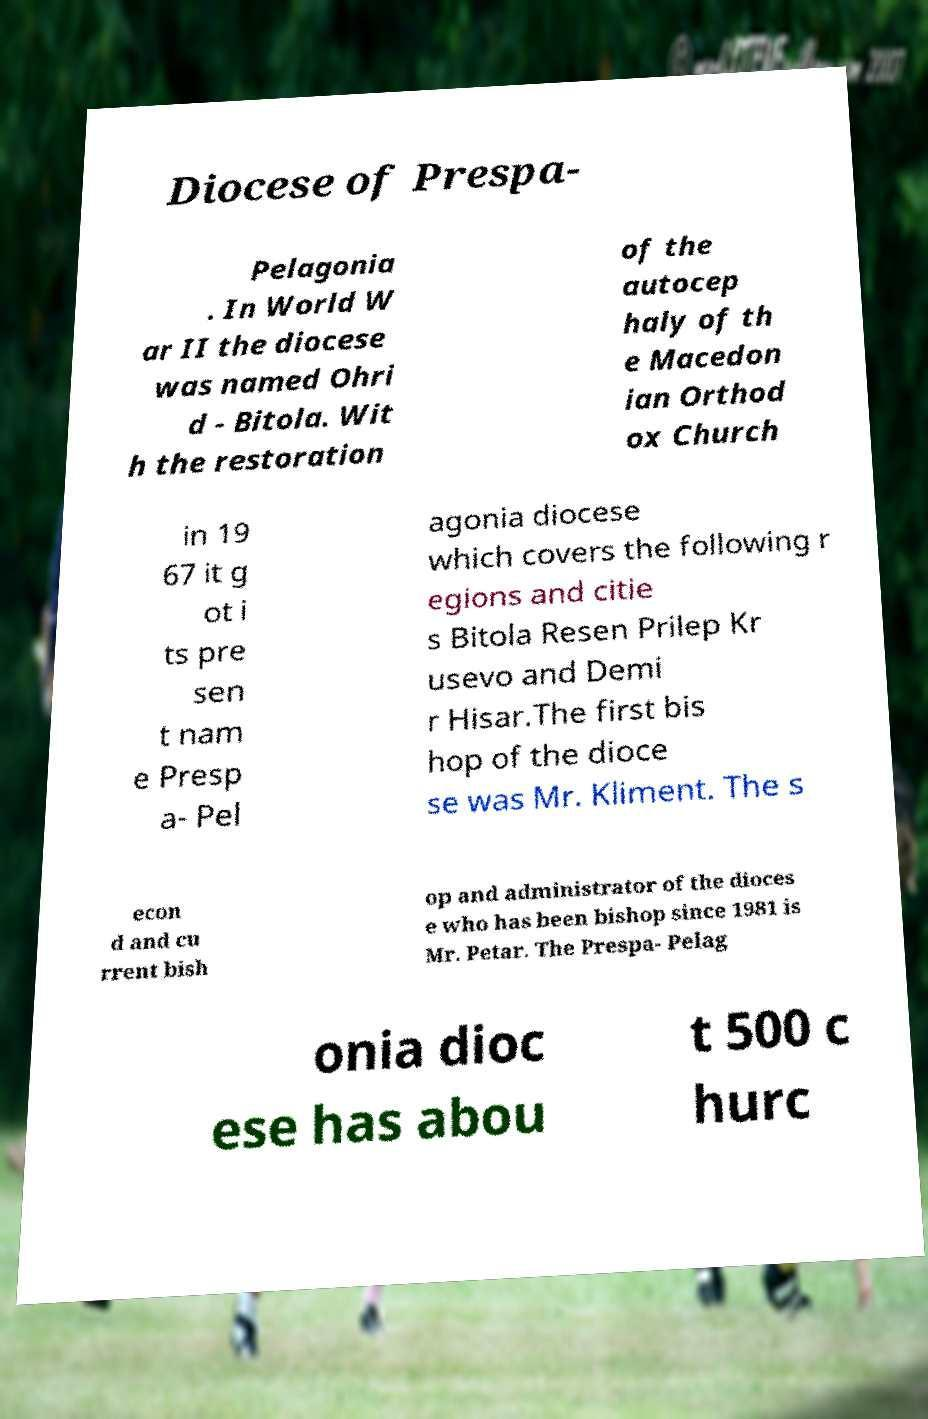Please identify and transcribe the text found in this image. Diocese of Prespa- Pelagonia . In World W ar II the diocese was named Ohri d - Bitola. Wit h the restoration of the autocep haly of th e Macedon ian Orthod ox Church in 19 67 it g ot i ts pre sen t nam e Presp a- Pel agonia diocese which covers the following r egions and citie s Bitola Resen Prilep Kr usevo and Demi r Hisar.The first bis hop of the dioce se was Mr. Kliment. The s econ d and cu rrent bish op and administrator of the dioces e who has been bishop since 1981 is Mr. Petar. The Prespa- Pelag onia dioc ese has abou t 500 c hurc 